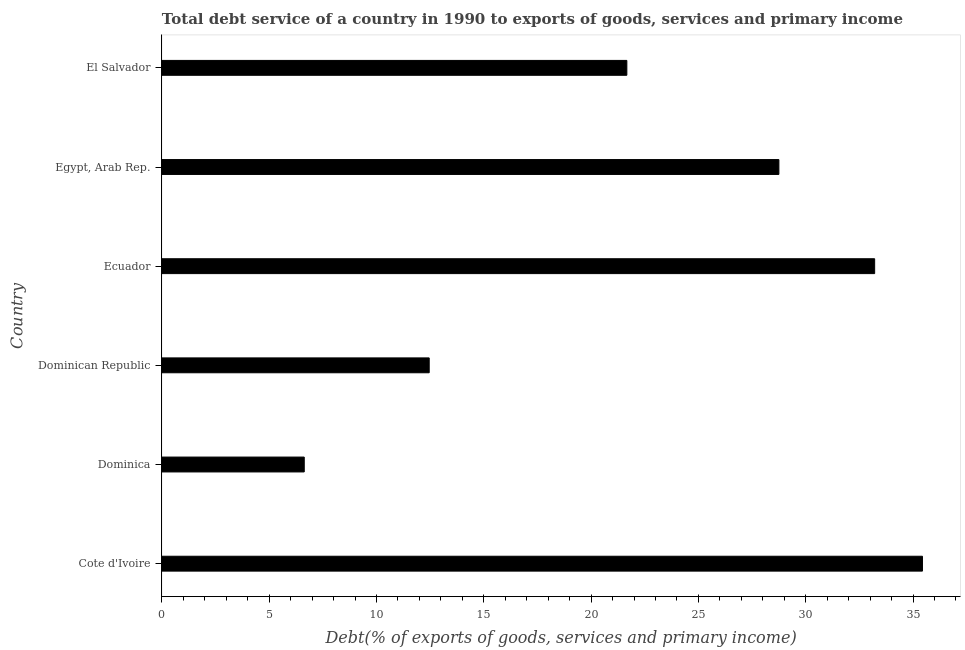What is the title of the graph?
Offer a very short reply. Total debt service of a country in 1990 to exports of goods, services and primary income. What is the label or title of the X-axis?
Ensure brevity in your answer.  Debt(% of exports of goods, services and primary income). What is the total debt service in Ecuador?
Provide a short and direct response. 33.21. Across all countries, what is the maximum total debt service?
Give a very brief answer. 35.44. Across all countries, what is the minimum total debt service?
Give a very brief answer. 6.63. In which country was the total debt service maximum?
Ensure brevity in your answer.  Cote d'Ivoire. In which country was the total debt service minimum?
Offer a very short reply. Dominica. What is the sum of the total debt service?
Give a very brief answer. 138.15. What is the difference between the total debt service in Egypt, Arab Rep. and El Salvador?
Offer a terse response. 7.08. What is the average total debt service per country?
Your answer should be very brief. 23.02. What is the median total debt service?
Your answer should be very brief. 25.21. In how many countries, is the total debt service greater than 5 %?
Provide a short and direct response. 6. What is the ratio of the total debt service in Ecuador to that in El Salvador?
Provide a succinct answer. 1.53. Is the difference between the total debt service in Dominican Republic and Ecuador greater than the difference between any two countries?
Your answer should be compact. No. What is the difference between the highest and the second highest total debt service?
Give a very brief answer. 2.23. Is the sum of the total debt service in Ecuador and Egypt, Arab Rep. greater than the maximum total debt service across all countries?
Make the answer very short. Yes. What is the difference between the highest and the lowest total debt service?
Keep it short and to the point. 28.81. In how many countries, is the total debt service greater than the average total debt service taken over all countries?
Provide a short and direct response. 3. How many bars are there?
Offer a very short reply. 6. Are all the bars in the graph horizontal?
Provide a short and direct response. Yes. What is the difference between two consecutive major ticks on the X-axis?
Your answer should be compact. 5. Are the values on the major ticks of X-axis written in scientific E-notation?
Your response must be concise. No. What is the Debt(% of exports of goods, services and primary income) in Cote d'Ivoire?
Keep it short and to the point. 35.44. What is the Debt(% of exports of goods, services and primary income) of Dominica?
Provide a succinct answer. 6.63. What is the Debt(% of exports of goods, services and primary income) in Dominican Republic?
Provide a succinct answer. 12.45. What is the Debt(% of exports of goods, services and primary income) of Ecuador?
Provide a succinct answer. 33.21. What is the Debt(% of exports of goods, services and primary income) of Egypt, Arab Rep.?
Keep it short and to the point. 28.75. What is the Debt(% of exports of goods, services and primary income) in El Salvador?
Your answer should be very brief. 21.66. What is the difference between the Debt(% of exports of goods, services and primary income) in Cote d'Ivoire and Dominica?
Keep it short and to the point. 28.81. What is the difference between the Debt(% of exports of goods, services and primary income) in Cote d'Ivoire and Dominican Republic?
Provide a succinct answer. 22.98. What is the difference between the Debt(% of exports of goods, services and primary income) in Cote d'Ivoire and Ecuador?
Give a very brief answer. 2.23. What is the difference between the Debt(% of exports of goods, services and primary income) in Cote d'Ivoire and Egypt, Arab Rep.?
Offer a terse response. 6.69. What is the difference between the Debt(% of exports of goods, services and primary income) in Cote d'Ivoire and El Salvador?
Provide a succinct answer. 13.77. What is the difference between the Debt(% of exports of goods, services and primary income) in Dominica and Dominican Republic?
Your answer should be very brief. -5.82. What is the difference between the Debt(% of exports of goods, services and primary income) in Dominica and Ecuador?
Make the answer very short. -26.58. What is the difference between the Debt(% of exports of goods, services and primary income) in Dominica and Egypt, Arab Rep.?
Provide a short and direct response. -22.12. What is the difference between the Debt(% of exports of goods, services and primary income) in Dominica and El Salvador?
Provide a succinct answer. -15.03. What is the difference between the Debt(% of exports of goods, services and primary income) in Dominican Republic and Ecuador?
Give a very brief answer. -20.76. What is the difference between the Debt(% of exports of goods, services and primary income) in Dominican Republic and Egypt, Arab Rep.?
Your answer should be very brief. -16.29. What is the difference between the Debt(% of exports of goods, services and primary income) in Dominican Republic and El Salvador?
Offer a very short reply. -9.21. What is the difference between the Debt(% of exports of goods, services and primary income) in Ecuador and Egypt, Arab Rep.?
Provide a succinct answer. 4.46. What is the difference between the Debt(% of exports of goods, services and primary income) in Ecuador and El Salvador?
Ensure brevity in your answer.  11.55. What is the difference between the Debt(% of exports of goods, services and primary income) in Egypt, Arab Rep. and El Salvador?
Your response must be concise. 7.08. What is the ratio of the Debt(% of exports of goods, services and primary income) in Cote d'Ivoire to that in Dominica?
Your response must be concise. 5.34. What is the ratio of the Debt(% of exports of goods, services and primary income) in Cote d'Ivoire to that in Dominican Republic?
Offer a terse response. 2.85. What is the ratio of the Debt(% of exports of goods, services and primary income) in Cote d'Ivoire to that in Ecuador?
Your answer should be very brief. 1.07. What is the ratio of the Debt(% of exports of goods, services and primary income) in Cote d'Ivoire to that in Egypt, Arab Rep.?
Provide a short and direct response. 1.23. What is the ratio of the Debt(% of exports of goods, services and primary income) in Cote d'Ivoire to that in El Salvador?
Keep it short and to the point. 1.64. What is the ratio of the Debt(% of exports of goods, services and primary income) in Dominica to that in Dominican Republic?
Ensure brevity in your answer.  0.53. What is the ratio of the Debt(% of exports of goods, services and primary income) in Dominica to that in Egypt, Arab Rep.?
Offer a very short reply. 0.23. What is the ratio of the Debt(% of exports of goods, services and primary income) in Dominica to that in El Salvador?
Give a very brief answer. 0.31. What is the ratio of the Debt(% of exports of goods, services and primary income) in Dominican Republic to that in Ecuador?
Give a very brief answer. 0.38. What is the ratio of the Debt(% of exports of goods, services and primary income) in Dominican Republic to that in Egypt, Arab Rep.?
Your answer should be compact. 0.43. What is the ratio of the Debt(% of exports of goods, services and primary income) in Dominican Republic to that in El Salvador?
Your response must be concise. 0.57. What is the ratio of the Debt(% of exports of goods, services and primary income) in Ecuador to that in Egypt, Arab Rep.?
Provide a succinct answer. 1.16. What is the ratio of the Debt(% of exports of goods, services and primary income) in Ecuador to that in El Salvador?
Give a very brief answer. 1.53. What is the ratio of the Debt(% of exports of goods, services and primary income) in Egypt, Arab Rep. to that in El Salvador?
Provide a succinct answer. 1.33. 